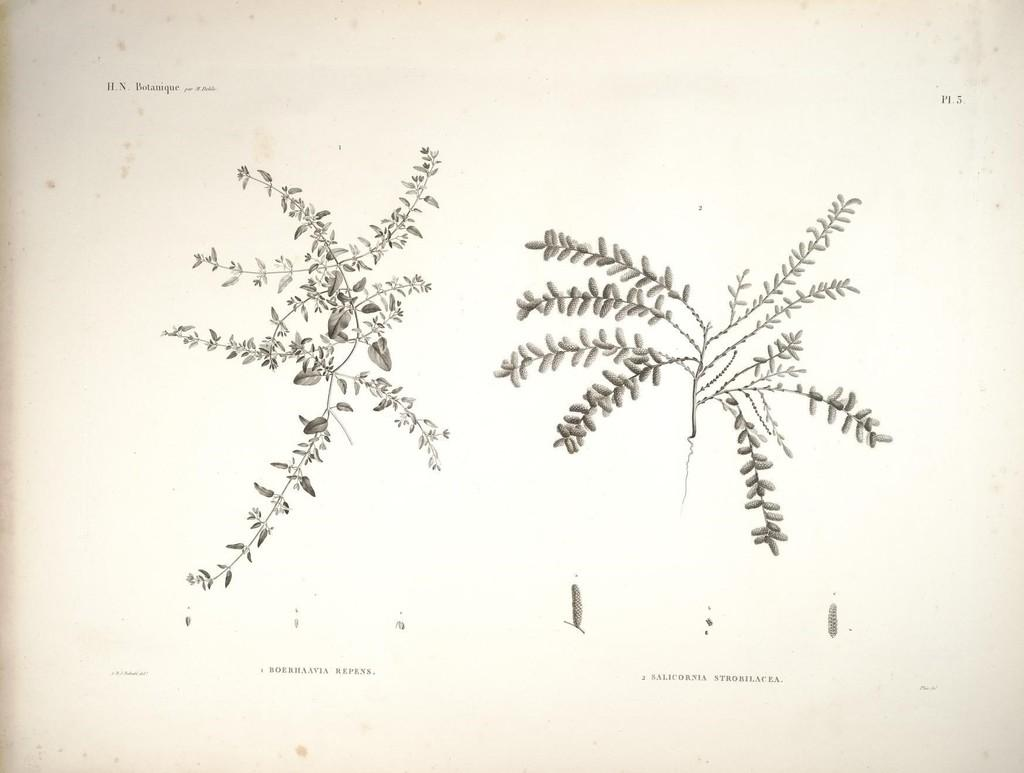What is depicted on the paper in the image? There are two pictures of a plant on the paper. What can be found at the top of the paper? There is text written at the top of the paper. What can be found at the bottom of the paper? There is text written at the bottom of the paper. What is the expert's opinion on the plant in the image? There is no expert present in the image, and therefore no opinion can be provided. What activity is taking place during the recess in the image? There is no recess or any activity related to it depicted in the image. 